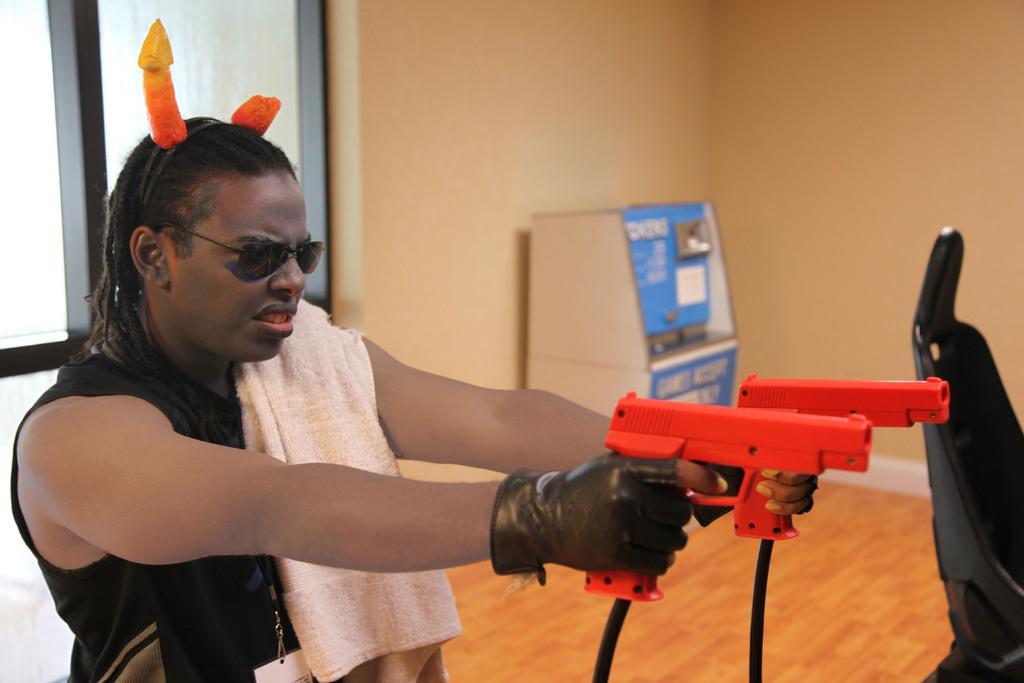Describe this image in one or two sentences. In this image there is a person holding objects in the foreground. There is floor at the bottom. There is a chair on the right corner. There is an object and wall in the background. And there is a window on the left corner. 